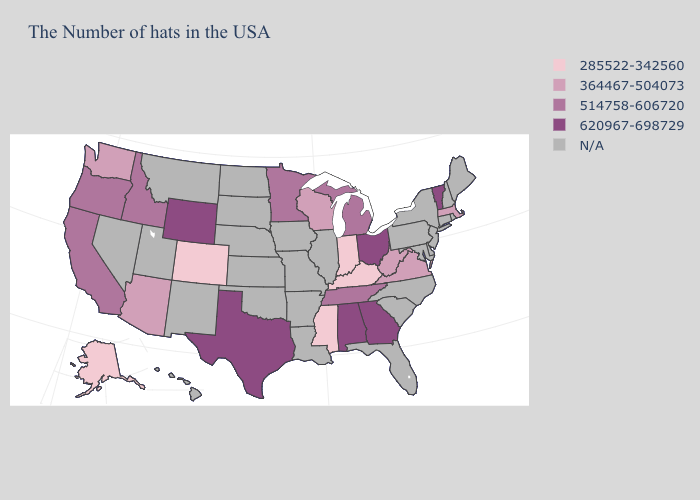Among the states that border South Dakota , does Minnesota have the lowest value?
Short answer required. Yes. Name the states that have a value in the range 285522-342560?
Give a very brief answer. Kentucky, Indiana, Mississippi, Colorado, Alaska. What is the lowest value in the USA?
Keep it brief. 285522-342560. Which states have the lowest value in the USA?
Be succinct. Kentucky, Indiana, Mississippi, Colorado, Alaska. Does the map have missing data?
Give a very brief answer. Yes. How many symbols are there in the legend?
Quick response, please. 5. Which states have the lowest value in the West?
Answer briefly. Colorado, Alaska. What is the value of Missouri?
Write a very short answer. N/A. Is the legend a continuous bar?
Quick response, please. No. Name the states that have a value in the range 514758-606720?
Answer briefly. Michigan, Tennessee, Minnesota, Idaho, California, Oregon. Among the states that border Illinois , does Kentucky have the lowest value?
Give a very brief answer. Yes. Name the states that have a value in the range N/A?
Keep it brief. Maine, Rhode Island, New Hampshire, Connecticut, New York, New Jersey, Delaware, Maryland, Pennsylvania, North Carolina, South Carolina, Florida, Illinois, Louisiana, Missouri, Arkansas, Iowa, Kansas, Nebraska, Oklahoma, South Dakota, North Dakota, New Mexico, Utah, Montana, Nevada, Hawaii. What is the highest value in the MidWest ?
Give a very brief answer. 620967-698729. Name the states that have a value in the range 364467-504073?
Write a very short answer. Massachusetts, Virginia, West Virginia, Wisconsin, Arizona, Washington. 